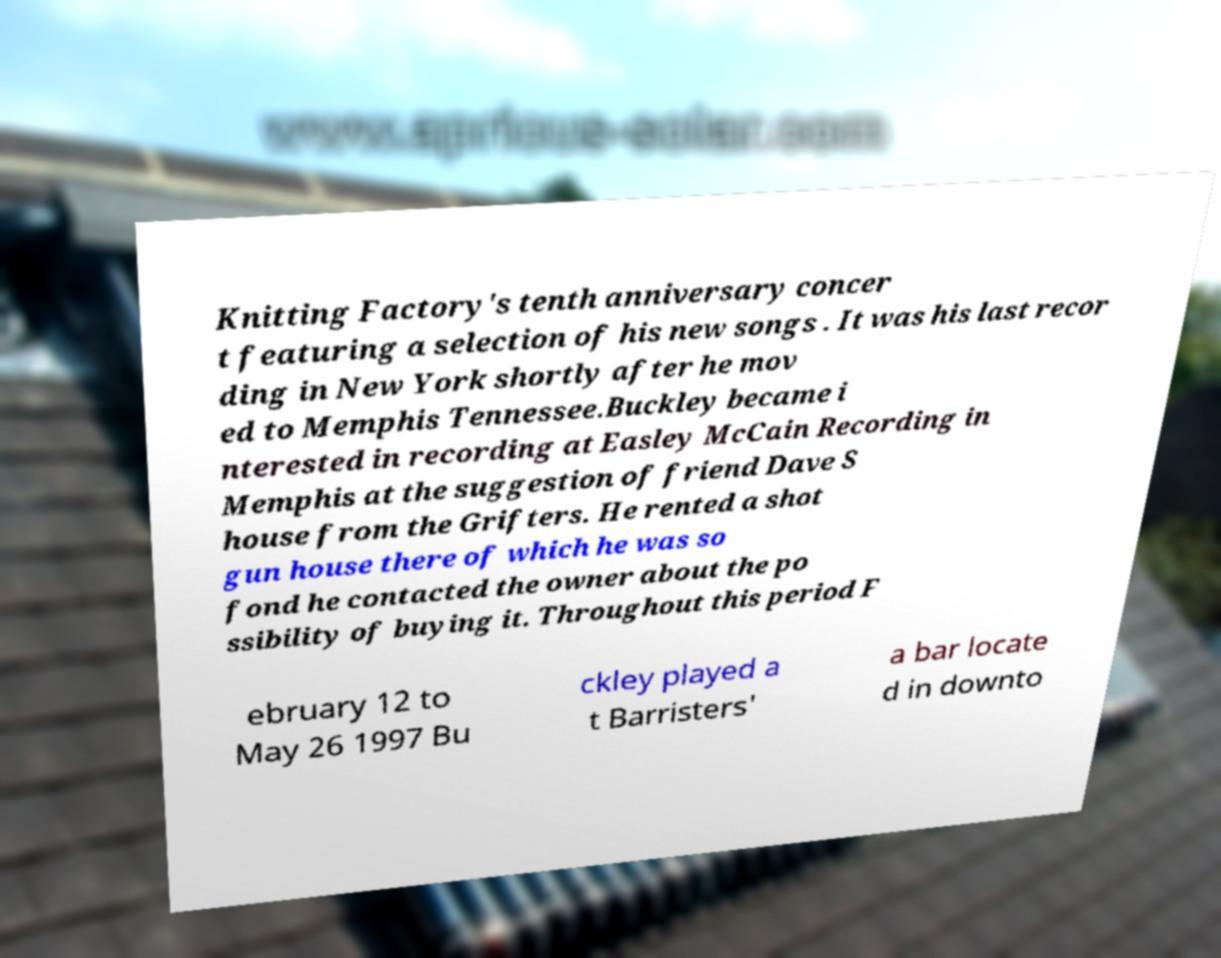For documentation purposes, I need the text within this image transcribed. Could you provide that? Knitting Factory's tenth anniversary concer t featuring a selection of his new songs . It was his last recor ding in New York shortly after he mov ed to Memphis Tennessee.Buckley became i nterested in recording at Easley McCain Recording in Memphis at the suggestion of friend Dave S house from the Grifters. He rented a shot gun house there of which he was so fond he contacted the owner about the po ssibility of buying it. Throughout this period F ebruary 12 to May 26 1997 Bu ckley played a t Barristers' a bar locate d in downto 